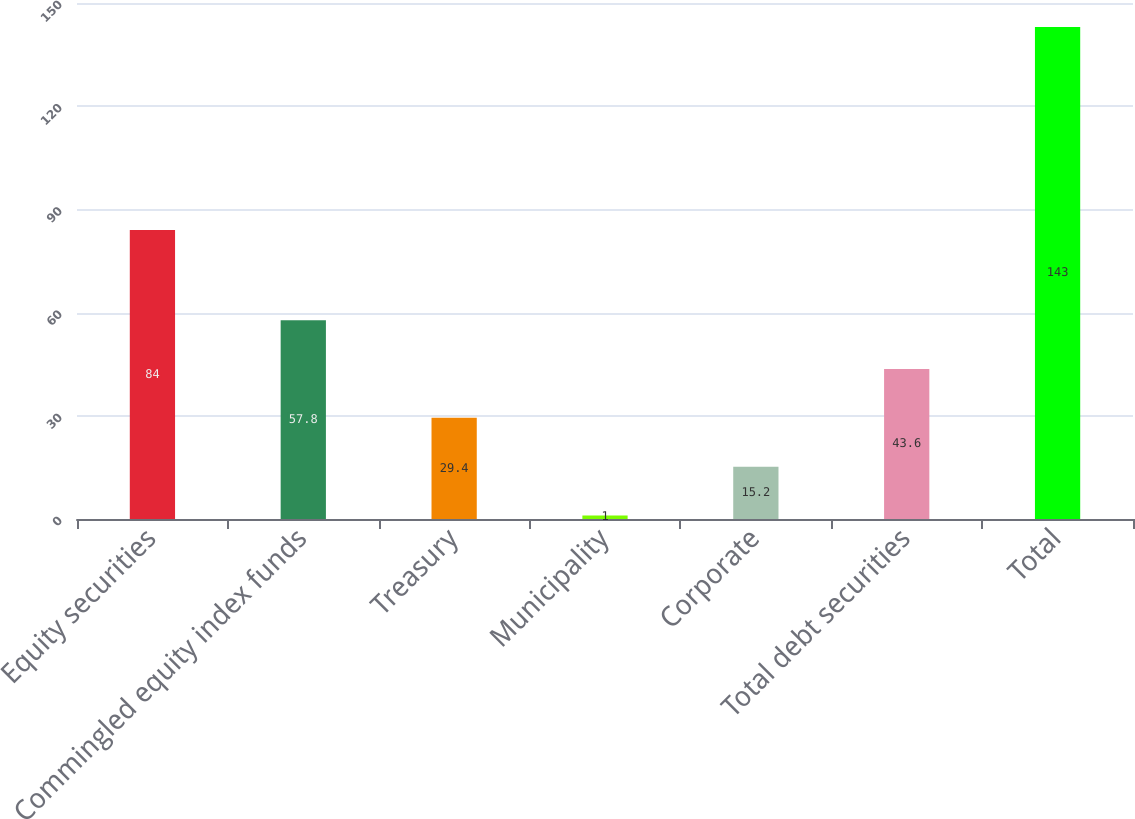Convert chart to OTSL. <chart><loc_0><loc_0><loc_500><loc_500><bar_chart><fcel>Equity securities<fcel>Commingled equity index funds<fcel>Treasury<fcel>Municipality<fcel>Corporate<fcel>Total debt securities<fcel>Total<nl><fcel>84<fcel>57.8<fcel>29.4<fcel>1<fcel>15.2<fcel>43.6<fcel>143<nl></chart> 